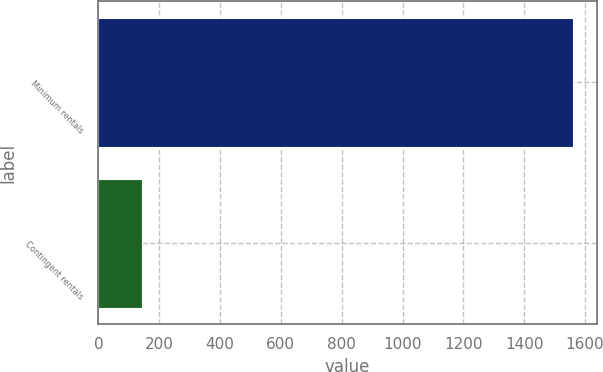Convert chart to OTSL. <chart><loc_0><loc_0><loc_500><loc_500><bar_chart><fcel>Minimum rentals<fcel>Contingent rentals<nl><fcel>1560<fcel>143<nl></chart> 